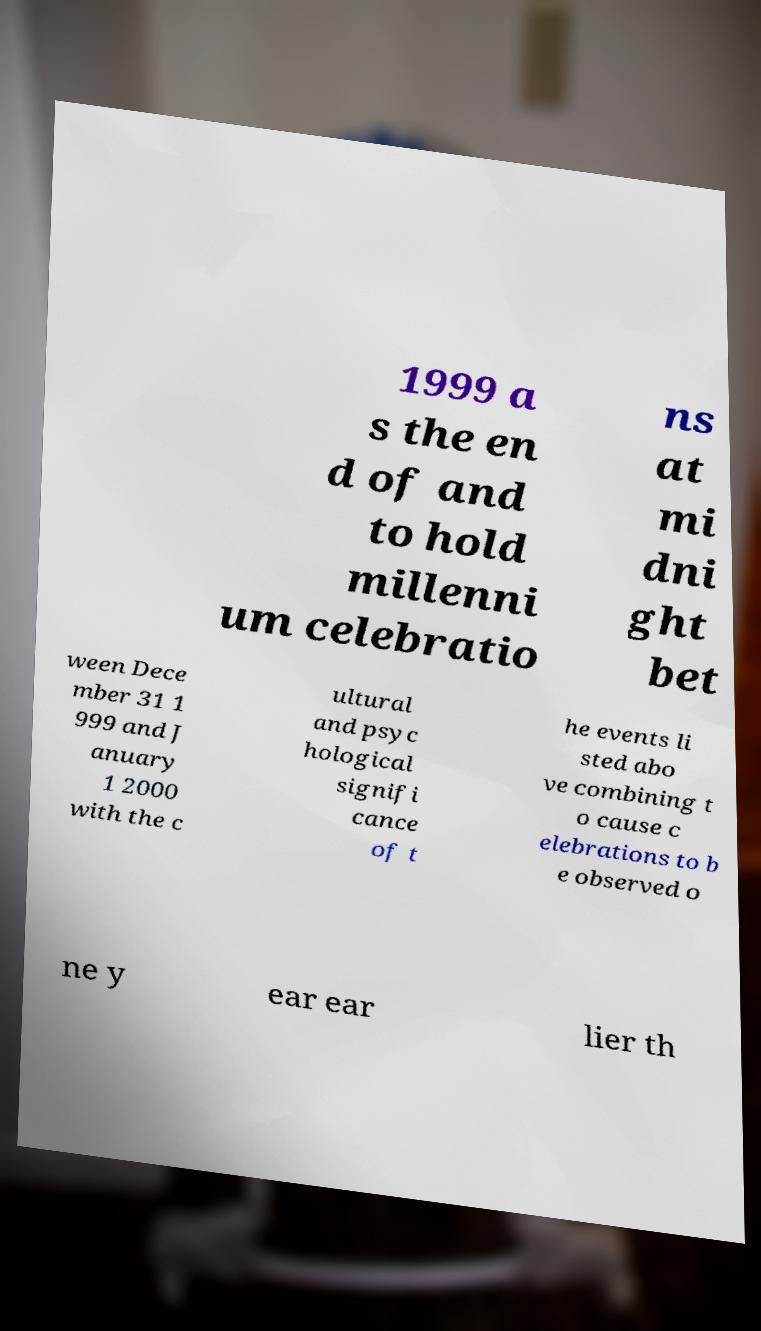Please read and relay the text visible in this image. What does it say? 1999 a s the en d of and to hold millenni um celebratio ns at mi dni ght bet ween Dece mber 31 1 999 and J anuary 1 2000 with the c ultural and psyc hological signifi cance of t he events li sted abo ve combining t o cause c elebrations to b e observed o ne y ear ear lier th 